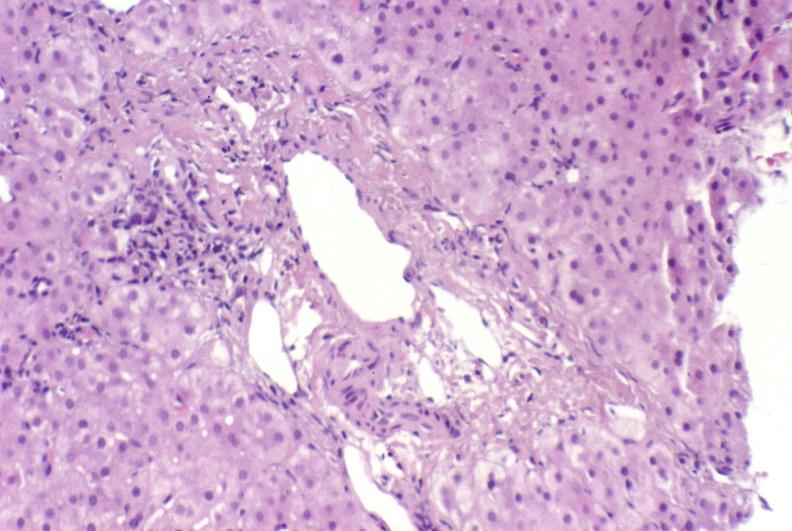s edema present?
Answer the question using a single word or phrase. No 